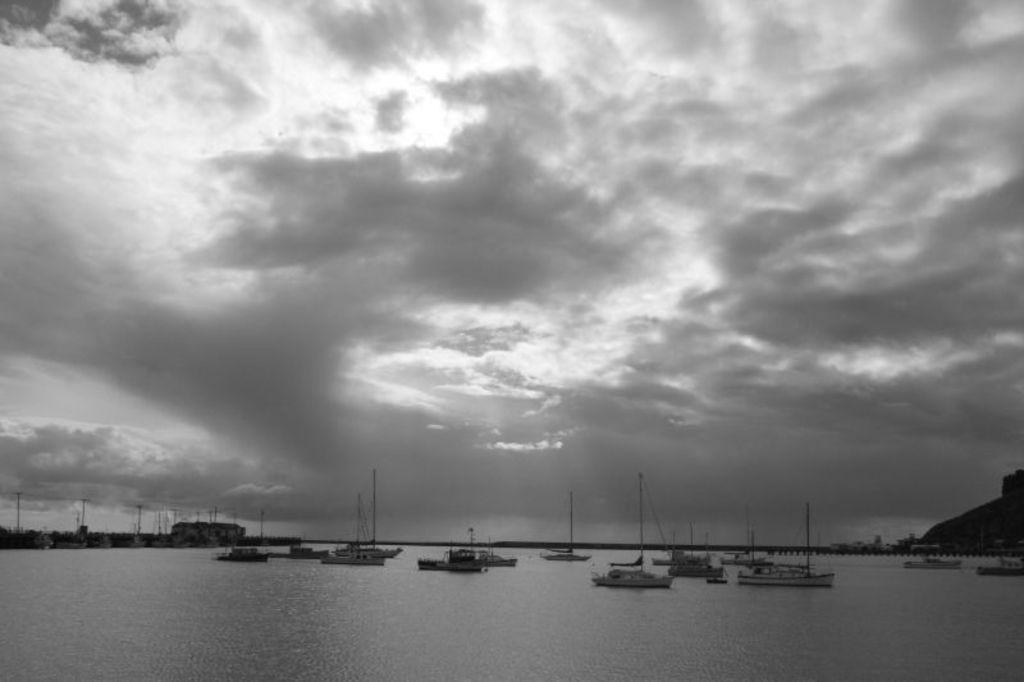How would you summarize this image in a sentence or two? In this picture we can see a group of boats on water, here we can see sheds, electric poles and some objects and we can see sky in the background. 